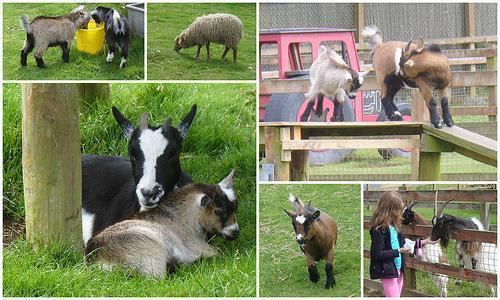How many different photos are there?
Give a very brief answer. 6. How many people are in these photos?
Give a very brief answer. 1. How many animals are not goats in the picture?
Give a very brief answer. 1. 